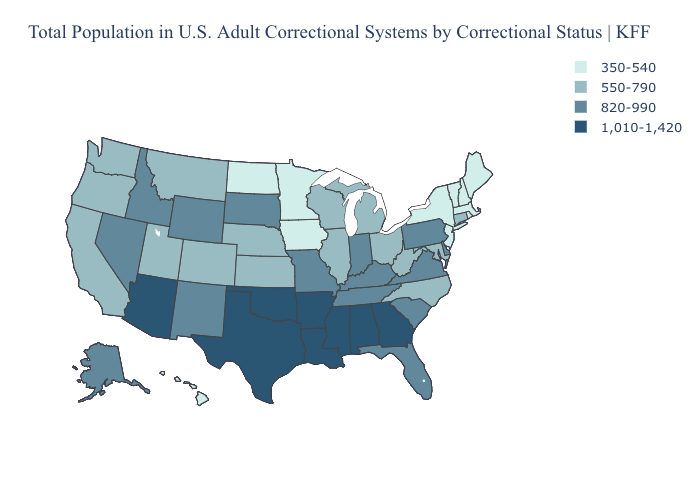What is the lowest value in the South?
Give a very brief answer. 550-790. Name the states that have a value in the range 1,010-1,420?
Short answer required. Alabama, Arizona, Arkansas, Georgia, Louisiana, Mississippi, Oklahoma, Texas. Name the states that have a value in the range 820-990?
Keep it brief. Alaska, Delaware, Florida, Idaho, Indiana, Kentucky, Missouri, Nevada, New Mexico, Pennsylvania, South Carolina, South Dakota, Tennessee, Virginia, Wyoming. What is the highest value in the USA?
Concise answer only. 1,010-1,420. What is the highest value in the USA?
Concise answer only. 1,010-1,420. Name the states that have a value in the range 1,010-1,420?
Answer briefly. Alabama, Arizona, Arkansas, Georgia, Louisiana, Mississippi, Oklahoma, Texas. Name the states that have a value in the range 1,010-1,420?
Write a very short answer. Alabama, Arizona, Arkansas, Georgia, Louisiana, Mississippi, Oklahoma, Texas. Name the states that have a value in the range 820-990?
Concise answer only. Alaska, Delaware, Florida, Idaho, Indiana, Kentucky, Missouri, Nevada, New Mexico, Pennsylvania, South Carolina, South Dakota, Tennessee, Virginia, Wyoming. What is the value of North Carolina?
Give a very brief answer. 550-790. Name the states that have a value in the range 820-990?
Short answer required. Alaska, Delaware, Florida, Idaho, Indiana, Kentucky, Missouri, Nevada, New Mexico, Pennsylvania, South Carolina, South Dakota, Tennessee, Virginia, Wyoming. Name the states that have a value in the range 350-540?
Quick response, please. Hawaii, Iowa, Maine, Massachusetts, Minnesota, New Hampshire, New Jersey, New York, North Dakota, Rhode Island, Vermont. Among the states that border Illinois , does Indiana have the highest value?
Answer briefly. Yes. Which states have the highest value in the USA?
Be succinct. Alabama, Arizona, Arkansas, Georgia, Louisiana, Mississippi, Oklahoma, Texas. What is the value of Arkansas?
Be succinct. 1,010-1,420. How many symbols are there in the legend?
Concise answer only. 4. 